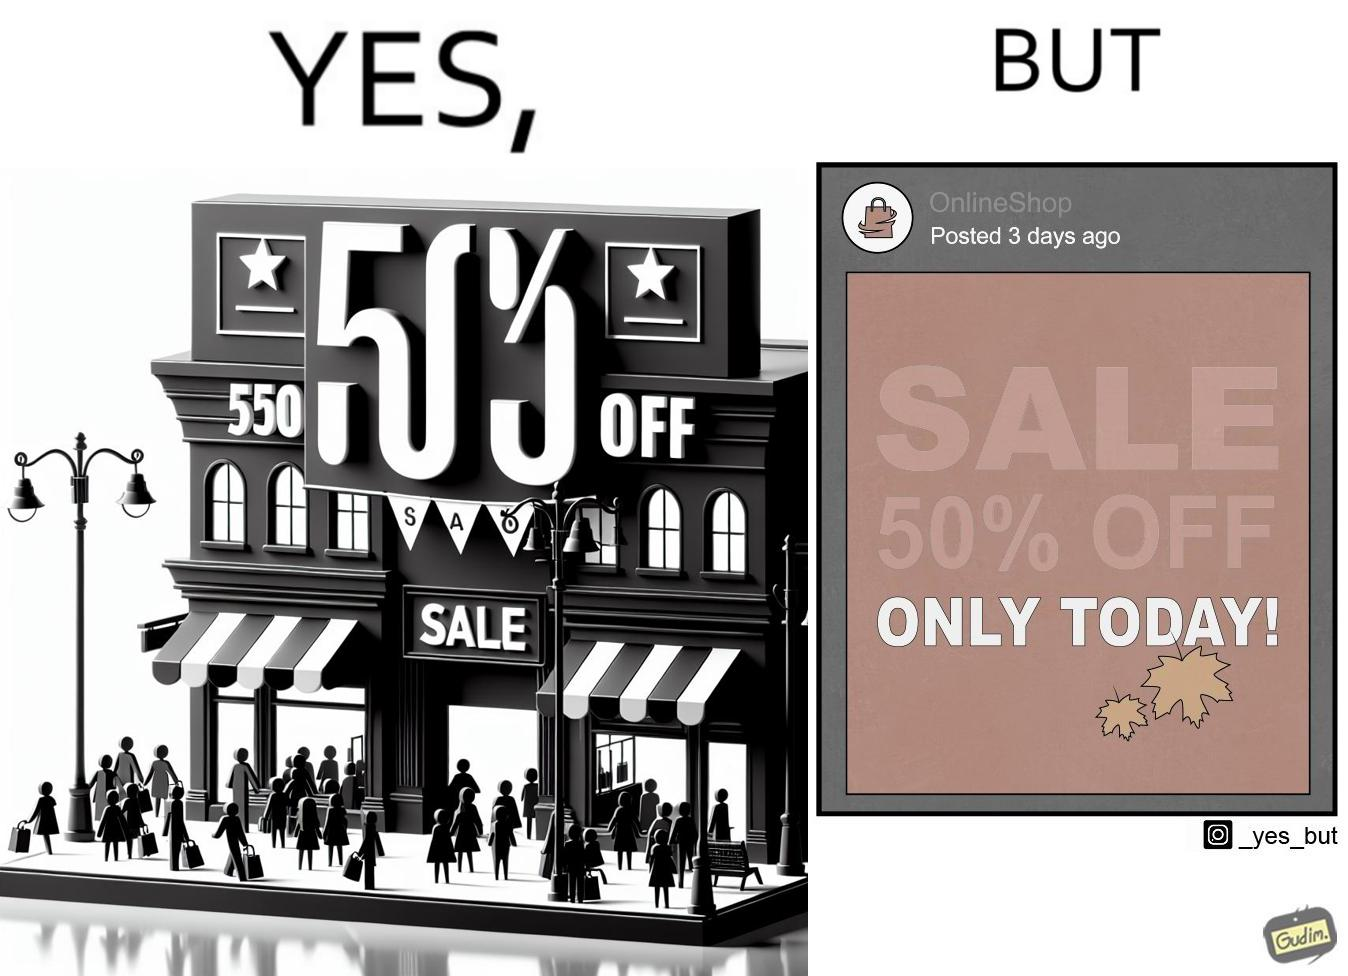Describe the content of this image. The image is ironic, because the poster of sale at a store is posted 3 days ago on a social media account which means the sale which was for only one day has become over 